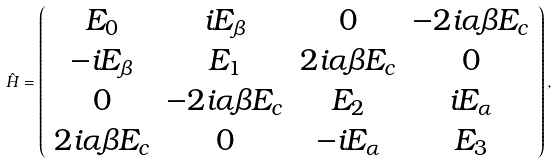<formula> <loc_0><loc_0><loc_500><loc_500>\hat { H } = \left ( \begin{array} { c c c c } E _ { 0 } & i E _ { \beta } & 0 & - 2 i \alpha \beta E _ { c } \\ - i E _ { \beta } & E _ { 1 } & 2 i \alpha \beta E _ { c } & 0 \\ 0 & - 2 i \alpha \beta E _ { c } & E _ { 2 } & i E _ { \alpha } \\ 2 i \alpha \beta E _ { c } & 0 & - i E _ { \alpha } & E _ { 3 } \end{array} \right ) ,</formula> 